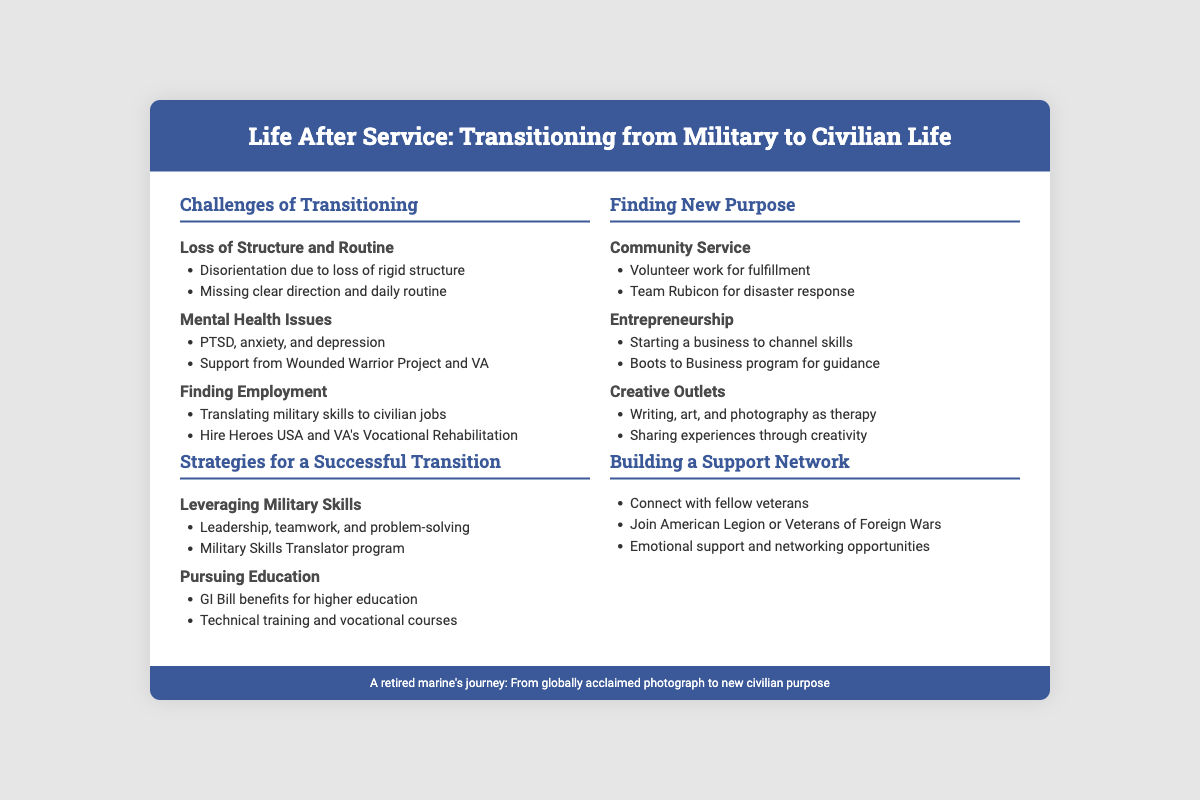What are the main challenges of transitioning? The document lists the challenges under the "Challenges of Transitioning" section, which include "Loss of Structure and Routine," "Mental Health Issues," and "Finding Employment."
Answer: Loss of Structure and Routine, Mental Health Issues, Finding Employment What program helps with translating military skills to civilian jobs? The document mentions "Hire Heroes USA" and "VA's Vocational Rehabilitation" as programs for employment transition.
Answer: Hire Heroes USA, VA's Vocational Rehabilitation What benefits can be pursued for higher education? The document states that "GI Bill benefits" can be utilized for higher education along with "Technical training and vocational courses."
Answer: GI Bill benefits Which organization is mentioned for community service? The document highlights "Team Rubicon" as a volunteer opportunity for disaster response.
Answer: Team Rubicon What is a strategy for finding new purpose after service? The document lists "Community Service," "Entrepreneurship," and "Creative Outlets" as strategies for a new purpose.
Answer: Community Service, Entrepreneurship, Creative Outlets What type of network does the document recommend building? The document suggests building a "Support Network" by connecting with fellow veterans and joining organizations.
Answer: Support Network Which mental health issues are highlighted in the document? The "Mental Health Issues" section lists "PTSD, anxiety, and depression."
Answer: PTSD, anxiety, and depression What is the focus of the "Boots to Business" program? The document states that it is for "Starting a business to channel skills."
Answer: Starting a business to channel skills 